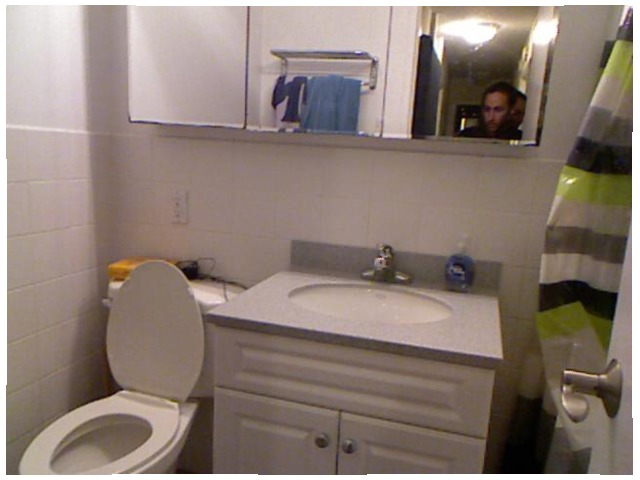<image>
Is there a light in the mirror? Yes. The light is contained within or inside the mirror, showing a containment relationship. 